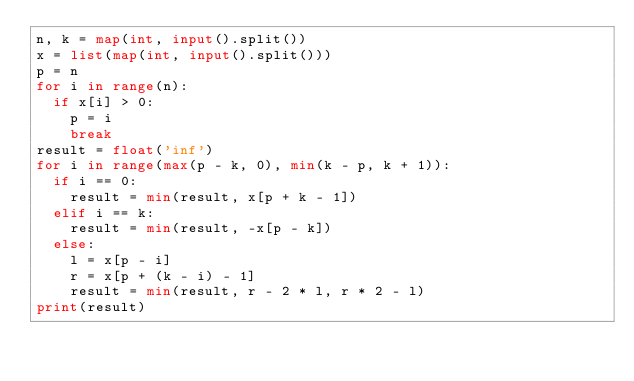Convert code to text. <code><loc_0><loc_0><loc_500><loc_500><_Python_>n, k = map(int, input().split())
x = list(map(int, input().split()))
p = n
for i in range(n):
  if x[i] > 0:
    p = i
    break
result = float('inf')
for i in range(max(p - k, 0), min(k - p, k + 1)):
  if i == 0:
    result = min(result, x[p + k - 1])
  elif i == k:
    result = min(result, -x[p - k])
  else:
    l = x[p - i]
    r = x[p + (k - i) - 1]
    result = min(result, r - 2 * l, r * 2 - l)
print(result)
</code> 